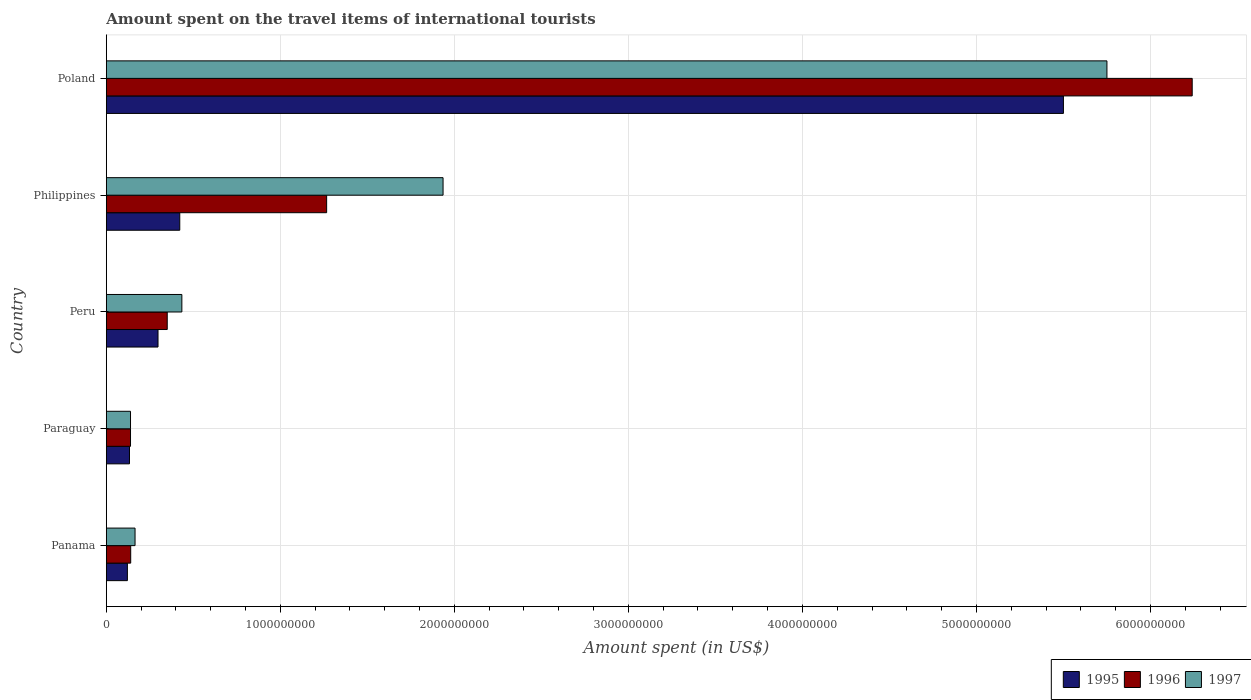How many groups of bars are there?
Offer a terse response. 5. Are the number of bars on each tick of the Y-axis equal?
Your response must be concise. Yes. How many bars are there on the 4th tick from the bottom?
Make the answer very short. 3. What is the label of the 4th group of bars from the top?
Offer a very short reply. Paraguay. In how many cases, is the number of bars for a given country not equal to the number of legend labels?
Make the answer very short. 0. What is the amount spent on the travel items of international tourists in 1995 in Peru?
Ensure brevity in your answer.  2.97e+08. Across all countries, what is the maximum amount spent on the travel items of international tourists in 1997?
Keep it short and to the point. 5.75e+09. Across all countries, what is the minimum amount spent on the travel items of international tourists in 1997?
Provide a short and direct response. 1.39e+08. In which country was the amount spent on the travel items of international tourists in 1995 minimum?
Make the answer very short. Panama. What is the total amount spent on the travel items of international tourists in 1996 in the graph?
Keep it short and to the point. 8.14e+09. What is the difference between the amount spent on the travel items of international tourists in 1995 in Panama and that in Philippines?
Ensure brevity in your answer.  -3.01e+08. What is the difference between the amount spent on the travel items of international tourists in 1996 in Peru and the amount spent on the travel items of international tourists in 1997 in Panama?
Give a very brief answer. 1.85e+08. What is the average amount spent on the travel items of international tourists in 1997 per country?
Give a very brief answer. 1.68e+09. What is the difference between the amount spent on the travel items of international tourists in 1996 and amount spent on the travel items of international tourists in 1997 in Paraguay?
Your answer should be very brief. 0. In how many countries, is the amount spent on the travel items of international tourists in 1996 greater than 4600000000 US$?
Provide a short and direct response. 1. What is the ratio of the amount spent on the travel items of international tourists in 1996 in Panama to that in Paraguay?
Provide a succinct answer. 1.01. Is the amount spent on the travel items of international tourists in 1997 in Panama less than that in Paraguay?
Your response must be concise. No. What is the difference between the highest and the second highest amount spent on the travel items of international tourists in 1996?
Ensure brevity in your answer.  4.97e+09. What is the difference between the highest and the lowest amount spent on the travel items of international tourists in 1997?
Ensure brevity in your answer.  5.61e+09. In how many countries, is the amount spent on the travel items of international tourists in 1996 greater than the average amount spent on the travel items of international tourists in 1996 taken over all countries?
Your answer should be very brief. 1. Is it the case that in every country, the sum of the amount spent on the travel items of international tourists in 1997 and amount spent on the travel items of international tourists in 1995 is greater than the amount spent on the travel items of international tourists in 1996?
Ensure brevity in your answer.  Yes. How many bars are there?
Your answer should be very brief. 15. How many countries are there in the graph?
Give a very brief answer. 5. Does the graph contain grids?
Your answer should be compact. Yes. Where does the legend appear in the graph?
Provide a short and direct response. Bottom right. How many legend labels are there?
Provide a succinct answer. 3. What is the title of the graph?
Provide a short and direct response. Amount spent on the travel items of international tourists. What is the label or title of the X-axis?
Provide a short and direct response. Amount spent (in US$). What is the label or title of the Y-axis?
Give a very brief answer. Country. What is the Amount spent (in US$) of 1995 in Panama?
Make the answer very short. 1.21e+08. What is the Amount spent (in US$) in 1996 in Panama?
Your response must be concise. 1.40e+08. What is the Amount spent (in US$) in 1997 in Panama?
Give a very brief answer. 1.65e+08. What is the Amount spent (in US$) in 1995 in Paraguay?
Offer a very short reply. 1.33e+08. What is the Amount spent (in US$) in 1996 in Paraguay?
Ensure brevity in your answer.  1.39e+08. What is the Amount spent (in US$) in 1997 in Paraguay?
Ensure brevity in your answer.  1.39e+08. What is the Amount spent (in US$) in 1995 in Peru?
Ensure brevity in your answer.  2.97e+08. What is the Amount spent (in US$) of 1996 in Peru?
Offer a terse response. 3.50e+08. What is the Amount spent (in US$) in 1997 in Peru?
Offer a terse response. 4.34e+08. What is the Amount spent (in US$) in 1995 in Philippines?
Provide a succinct answer. 4.22e+08. What is the Amount spent (in US$) in 1996 in Philippines?
Offer a terse response. 1.27e+09. What is the Amount spent (in US$) in 1997 in Philippines?
Provide a short and direct response. 1.94e+09. What is the Amount spent (in US$) in 1995 in Poland?
Offer a terse response. 5.50e+09. What is the Amount spent (in US$) in 1996 in Poland?
Make the answer very short. 6.24e+09. What is the Amount spent (in US$) in 1997 in Poland?
Your answer should be compact. 5.75e+09. Across all countries, what is the maximum Amount spent (in US$) of 1995?
Provide a succinct answer. 5.50e+09. Across all countries, what is the maximum Amount spent (in US$) of 1996?
Keep it short and to the point. 6.24e+09. Across all countries, what is the maximum Amount spent (in US$) in 1997?
Keep it short and to the point. 5.75e+09. Across all countries, what is the minimum Amount spent (in US$) of 1995?
Give a very brief answer. 1.21e+08. Across all countries, what is the minimum Amount spent (in US$) of 1996?
Make the answer very short. 1.39e+08. Across all countries, what is the minimum Amount spent (in US$) in 1997?
Provide a succinct answer. 1.39e+08. What is the total Amount spent (in US$) in 1995 in the graph?
Your response must be concise. 6.47e+09. What is the total Amount spent (in US$) of 1996 in the graph?
Make the answer very short. 8.14e+09. What is the total Amount spent (in US$) in 1997 in the graph?
Make the answer very short. 8.42e+09. What is the difference between the Amount spent (in US$) in 1995 in Panama and that in Paraguay?
Offer a very short reply. -1.20e+07. What is the difference between the Amount spent (in US$) of 1997 in Panama and that in Paraguay?
Provide a short and direct response. 2.60e+07. What is the difference between the Amount spent (in US$) in 1995 in Panama and that in Peru?
Provide a succinct answer. -1.76e+08. What is the difference between the Amount spent (in US$) in 1996 in Panama and that in Peru?
Keep it short and to the point. -2.10e+08. What is the difference between the Amount spent (in US$) of 1997 in Panama and that in Peru?
Offer a terse response. -2.69e+08. What is the difference between the Amount spent (in US$) of 1995 in Panama and that in Philippines?
Your response must be concise. -3.01e+08. What is the difference between the Amount spent (in US$) in 1996 in Panama and that in Philippines?
Give a very brief answer. -1.13e+09. What is the difference between the Amount spent (in US$) in 1997 in Panama and that in Philippines?
Make the answer very short. -1.77e+09. What is the difference between the Amount spent (in US$) of 1995 in Panama and that in Poland?
Keep it short and to the point. -5.38e+09. What is the difference between the Amount spent (in US$) of 1996 in Panama and that in Poland?
Your response must be concise. -6.10e+09. What is the difference between the Amount spent (in US$) of 1997 in Panama and that in Poland?
Your answer should be very brief. -5.58e+09. What is the difference between the Amount spent (in US$) of 1995 in Paraguay and that in Peru?
Your response must be concise. -1.64e+08. What is the difference between the Amount spent (in US$) in 1996 in Paraguay and that in Peru?
Give a very brief answer. -2.11e+08. What is the difference between the Amount spent (in US$) in 1997 in Paraguay and that in Peru?
Make the answer very short. -2.95e+08. What is the difference between the Amount spent (in US$) in 1995 in Paraguay and that in Philippines?
Provide a short and direct response. -2.89e+08. What is the difference between the Amount spent (in US$) in 1996 in Paraguay and that in Philippines?
Your response must be concise. -1.13e+09. What is the difference between the Amount spent (in US$) in 1997 in Paraguay and that in Philippines?
Offer a terse response. -1.80e+09. What is the difference between the Amount spent (in US$) of 1995 in Paraguay and that in Poland?
Provide a succinct answer. -5.37e+09. What is the difference between the Amount spent (in US$) of 1996 in Paraguay and that in Poland?
Provide a short and direct response. -6.10e+09. What is the difference between the Amount spent (in US$) in 1997 in Paraguay and that in Poland?
Offer a very short reply. -5.61e+09. What is the difference between the Amount spent (in US$) in 1995 in Peru and that in Philippines?
Give a very brief answer. -1.25e+08. What is the difference between the Amount spent (in US$) in 1996 in Peru and that in Philippines?
Make the answer very short. -9.16e+08. What is the difference between the Amount spent (in US$) in 1997 in Peru and that in Philippines?
Make the answer very short. -1.50e+09. What is the difference between the Amount spent (in US$) of 1995 in Peru and that in Poland?
Make the answer very short. -5.20e+09. What is the difference between the Amount spent (in US$) of 1996 in Peru and that in Poland?
Your answer should be very brief. -5.89e+09. What is the difference between the Amount spent (in US$) in 1997 in Peru and that in Poland?
Keep it short and to the point. -5.32e+09. What is the difference between the Amount spent (in US$) in 1995 in Philippines and that in Poland?
Your response must be concise. -5.08e+09. What is the difference between the Amount spent (in US$) of 1996 in Philippines and that in Poland?
Provide a succinct answer. -4.97e+09. What is the difference between the Amount spent (in US$) in 1997 in Philippines and that in Poland?
Offer a very short reply. -3.82e+09. What is the difference between the Amount spent (in US$) of 1995 in Panama and the Amount spent (in US$) of 1996 in Paraguay?
Your answer should be compact. -1.80e+07. What is the difference between the Amount spent (in US$) of 1995 in Panama and the Amount spent (in US$) of 1997 in Paraguay?
Keep it short and to the point. -1.80e+07. What is the difference between the Amount spent (in US$) in 1996 in Panama and the Amount spent (in US$) in 1997 in Paraguay?
Provide a short and direct response. 1.00e+06. What is the difference between the Amount spent (in US$) of 1995 in Panama and the Amount spent (in US$) of 1996 in Peru?
Your response must be concise. -2.29e+08. What is the difference between the Amount spent (in US$) of 1995 in Panama and the Amount spent (in US$) of 1997 in Peru?
Provide a short and direct response. -3.13e+08. What is the difference between the Amount spent (in US$) of 1996 in Panama and the Amount spent (in US$) of 1997 in Peru?
Provide a short and direct response. -2.94e+08. What is the difference between the Amount spent (in US$) of 1995 in Panama and the Amount spent (in US$) of 1996 in Philippines?
Your answer should be very brief. -1.14e+09. What is the difference between the Amount spent (in US$) in 1995 in Panama and the Amount spent (in US$) in 1997 in Philippines?
Provide a short and direct response. -1.81e+09. What is the difference between the Amount spent (in US$) of 1996 in Panama and the Amount spent (in US$) of 1997 in Philippines?
Make the answer very short. -1.80e+09. What is the difference between the Amount spent (in US$) in 1995 in Panama and the Amount spent (in US$) in 1996 in Poland?
Provide a short and direct response. -6.12e+09. What is the difference between the Amount spent (in US$) in 1995 in Panama and the Amount spent (in US$) in 1997 in Poland?
Your answer should be compact. -5.63e+09. What is the difference between the Amount spent (in US$) of 1996 in Panama and the Amount spent (in US$) of 1997 in Poland?
Provide a short and direct response. -5.61e+09. What is the difference between the Amount spent (in US$) of 1995 in Paraguay and the Amount spent (in US$) of 1996 in Peru?
Your answer should be very brief. -2.17e+08. What is the difference between the Amount spent (in US$) in 1995 in Paraguay and the Amount spent (in US$) in 1997 in Peru?
Provide a succinct answer. -3.01e+08. What is the difference between the Amount spent (in US$) of 1996 in Paraguay and the Amount spent (in US$) of 1997 in Peru?
Ensure brevity in your answer.  -2.95e+08. What is the difference between the Amount spent (in US$) in 1995 in Paraguay and the Amount spent (in US$) in 1996 in Philippines?
Offer a terse response. -1.13e+09. What is the difference between the Amount spent (in US$) in 1995 in Paraguay and the Amount spent (in US$) in 1997 in Philippines?
Keep it short and to the point. -1.80e+09. What is the difference between the Amount spent (in US$) of 1996 in Paraguay and the Amount spent (in US$) of 1997 in Philippines?
Your answer should be compact. -1.80e+09. What is the difference between the Amount spent (in US$) of 1995 in Paraguay and the Amount spent (in US$) of 1996 in Poland?
Offer a terse response. -6.11e+09. What is the difference between the Amount spent (in US$) in 1995 in Paraguay and the Amount spent (in US$) in 1997 in Poland?
Your answer should be very brief. -5.62e+09. What is the difference between the Amount spent (in US$) of 1996 in Paraguay and the Amount spent (in US$) of 1997 in Poland?
Provide a short and direct response. -5.61e+09. What is the difference between the Amount spent (in US$) in 1995 in Peru and the Amount spent (in US$) in 1996 in Philippines?
Provide a short and direct response. -9.69e+08. What is the difference between the Amount spent (in US$) of 1995 in Peru and the Amount spent (in US$) of 1997 in Philippines?
Keep it short and to the point. -1.64e+09. What is the difference between the Amount spent (in US$) of 1996 in Peru and the Amount spent (in US$) of 1997 in Philippines?
Your answer should be compact. -1.58e+09. What is the difference between the Amount spent (in US$) in 1995 in Peru and the Amount spent (in US$) in 1996 in Poland?
Ensure brevity in your answer.  -5.94e+09. What is the difference between the Amount spent (in US$) in 1995 in Peru and the Amount spent (in US$) in 1997 in Poland?
Offer a very short reply. -5.45e+09. What is the difference between the Amount spent (in US$) in 1996 in Peru and the Amount spent (in US$) in 1997 in Poland?
Give a very brief answer. -5.40e+09. What is the difference between the Amount spent (in US$) in 1995 in Philippines and the Amount spent (in US$) in 1996 in Poland?
Your answer should be compact. -5.82e+09. What is the difference between the Amount spent (in US$) in 1995 in Philippines and the Amount spent (in US$) in 1997 in Poland?
Make the answer very short. -5.33e+09. What is the difference between the Amount spent (in US$) in 1996 in Philippines and the Amount spent (in US$) in 1997 in Poland?
Provide a short and direct response. -4.48e+09. What is the average Amount spent (in US$) in 1995 per country?
Offer a very short reply. 1.29e+09. What is the average Amount spent (in US$) of 1996 per country?
Offer a very short reply. 1.63e+09. What is the average Amount spent (in US$) in 1997 per country?
Give a very brief answer. 1.68e+09. What is the difference between the Amount spent (in US$) of 1995 and Amount spent (in US$) of 1996 in Panama?
Ensure brevity in your answer.  -1.90e+07. What is the difference between the Amount spent (in US$) in 1995 and Amount spent (in US$) in 1997 in Panama?
Offer a very short reply. -4.40e+07. What is the difference between the Amount spent (in US$) of 1996 and Amount spent (in US$) of 1997 in Panama?
Offer a terse response. -2.50e+07. What is the difference between the Amount spent (in US$) of 1995 and Amount spent (in US$) of 1996 in Paraguay?
Make the answer very short. -6.00e+06. What is the difference between the Amount spent (in US$) of 1995 and Amount spent (in US$) of 1997 in Paraguay?
Your response must be concise. -6.00e+06. What is the difference between the Amount spent (in US$) of 1996 and Amount spent (in US$) of 1997 in Paraguay?
Provide a short and direct response. 0. What is the difference between the Amount spent (in US$) in 1995 and Amount spent (in US$) in 1996 in Peru?
Keep it short and to the point. -5.30e+07. What is the difference between the Amount spent (in US$) in 1995 and Amount spent (in US$) in 1997 in Peru?
Offer a terse response. -1.37e+08. What is the difference between the Amount spent (in US$) of 1996 and Amount spent (in US$) of 1997 in Peru?
Your answer should be very brief. -8.40e+07. What is the difference between the Amount spent (in US$) of 1995 and Amount spent (in US$) of 1996 in Philippines?
Keep it short and to the point. -8.44e+08. What is the difference between the Amount spent (in US$) of 1995 and Amount spent (in US$) of 1997 in Philippines?
Provide a short and direct response. -1.51e+09. What is the difference between the Amount spent (in US$) of 1996 and Amount spent (in US$) of 1997 in Philippines?
Keep it short and to the point. -6.69e+08. What is the difference between the Amount spent (in US$) of 1995 and Amount spent (in US$) of 1996 in Poland?
Provide a short and direct response. -7.40e+08. What is the difference between the Amount spent (in US$) of 1995 and Amount spent (in US$) of 1997 in Poland?
Your response must be concise. -2.50e+08. What is the difference between the Amount spent (in US$) of 1996 and Amount spent (in US$) of 1997 in Poland?
Ensure brevity in your answer.  4.90e+08. What is the ratio of the Amount spent (in US$) in 1995 in Panama to that in Paraguay?
Offer a terse response. 0.91. What is the ratio of the Amount spent (in US$) of 1996 in Panama to that in Paraguay?
Keep it short and to the point. 1.01. What is the ratio of the Amount spent (in US$) in 1997 in Panama to that in Paraguay?
Give a very brief answer. 1.19. What is the ratio of the Amount spent (in US$) of 1995 in Panama to that in Peru?
Your answer should be very brief. 0.41. What is the ratio of the Amount spent (in US$) in 1996 in Panama to that in Peru?
Keep it short and to the point. 0.4. What is the ratio of the Amount spent (in US$) of 1997 in Panama to that in Peru?
Make the answer very short. 0.38. What is the ratio of the Amount spent (in US$) in 1995 in Panama to that in Philippines?
Provide a succinct answer. 0.29. What is the ratio of the Amount spent (in US$) in 1996 in Panama to that in Philippines?
Make the answer very short. 0.11. What is the ratio of the Amount spent (in US$) of 1997 in Panama to that in Philippines?
Provide a short and direct response. 0.09. What is the ratio of the Amount spent (in US$) of 1995 in Panama to that in Poland?
Ensure brevity in your answer.  0.02. What is the ratio of the Amount spent (in US$) in 1996 in Panama to that in Poland?
Give a very brief answer. 0.02. What is the ratio of the Amount spent (in US$) of 1997 in Panama to that in Poland?
Offer a very short reply. 0.03. What is the ratio of the Amount spent (in US$) of 1995 in Paraguay to that in Peru?
Offer a terse response. 0.45. What is the ratio of the Amount spent (in US$) in 1996 in Paraguay to that in Peru?
Offer a very short reply. 0.4. What is the ratio of the Amount spent (in US$) of 1997 in Paraguay to that in Peru?
Give a very brief answer. 0.32. What is the ratio of the Amount spent (in US$) in 1995 in Paraguay to that in Philippines?
Ensure brevity in your answer.  0.32. What is the ratio of the Amount spent (in US$) of 1996 in Paraguay to that in Philippines?
Give a very brief answer. 0.11. What is the ratio of the Amount spent (in US$) of 1997 in Paraguay to that in Philippines?
Give a very brief answer. 0.07. What is the ratio of the Amount spent (in US$) in 1995 in Paraguay to that in Poland?
Ensure brevity in your answer.  0.02. What is the ratio of the Amount spent (in US$) of 1996 in Paraguay to that in Poland?
Provide a succinct answer. 0.02. What is the ratio of the Amount spent (in US$) of 1997 in Paraguay to that in Poland?
Offer a terse response. 0.02. What is the ratio of the Amount spent (in US$) in 1995 in Peru to that in Philippines?
Keep it short and to the point. 0.7. What is the ratio of the Amount spent (in US$) of 1996 in Peru to that in Philippines?
Your answer should be compact. 0.28. What is the ratio of the Amount spent (in US$) of 1997 in Peru to that in Philippines?
Your answer should be compact. 0.22. What is the ratio of the Amount spent (in US$) in 1995 in Peru to that in Poland?
Provide a succinct answer. 0.05. What is the ratio of the Amount spent (in US$) of 1996 in Peru to that in Poland?
Keep it short and to the point. 0.06. What is the ratio of the Amount spent (in US$) of 1997 in Peru to that in Poland?
Provide a succinct answer. 0.08. What is the ratio of the Amount spent (in US$) in 1995 in Philippines to that in Poland?
Provide a short and direct response. 0.08. What is the ratio of the Amount spent (in US$) of 1996 in Philippines to that in Poland?
Your answer should be very brief. 0.2. What is the ratio of the Amount spent (in US$) of 1997 in Philippines to that in Poland?
Your response must be concise. 0.34. What is the difference between the highest and the second highest Amount spent (in US$) of 1995?
Provide a short and direct response. 5.08e+09. What is the difference between the highest and the second highest Amount spent (in US$) of 1996?
Make the answer very short. 4.97e+09. What is the difference between the highest and the second highest Amount spent (in US$) in 1997?
Make the answer very short. 3.82e+09. What is the difference between the highest and the lowest Amount spent (in US$) in 1995?
Make the answer very short. 5.38e+09. What is the difference between the highest and the lowest Amount spent (in US$) in 1996?
Make the answer very short. 6.10e+09. What is the difference between the highest and the lowest Amount spent (in US$) of 1997?
Your answer should be very brief. 5.61e+09. 